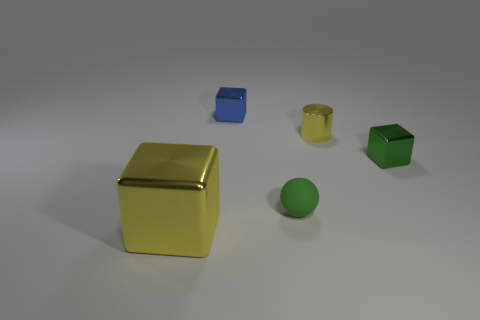Subtract 1 blocks. How many blocks are left? 2 Add 2 matte spheres. How many objects exist? 7 Subtract all cylinders. How many objects are left? 4 Subtract 0 blue spheres. How many objects are left? 5 Subtract all red spheres. Subtract all blocks. How many objects are left? 2 Add 4 small green balls. How many small green balls are left? 5 Add 5 blocks. How many blocks exist? 8 